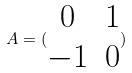Convert formula to latex. <formula><loc_0><loc_0><loc_500><loc_500>A = ( \begin{matrix} 0 & 1 \\ - 1 & 0 \end{matrix} )</formula> 